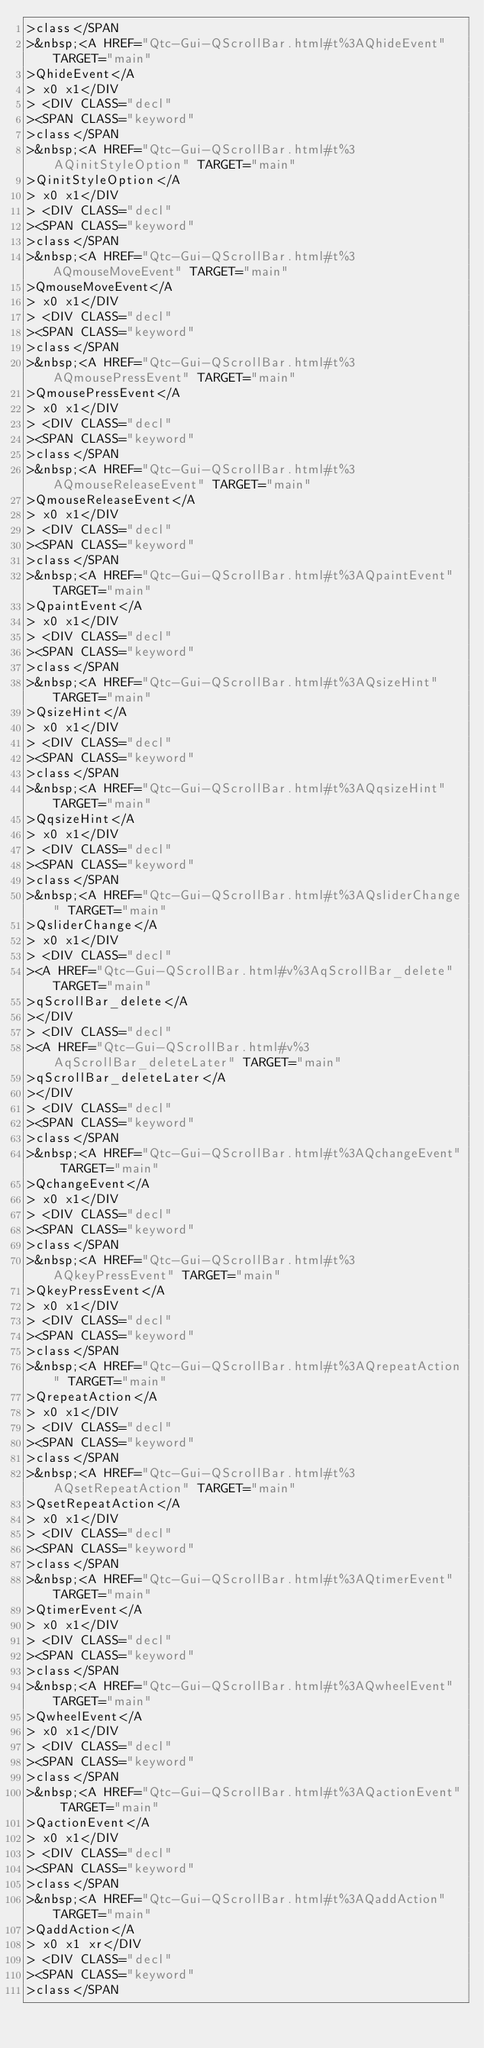Convert code to text. <code><loc_0><loc_0><loc_500><loc_500><_HTML_>>class</SPAN
>&nbsp;<A HREF="Qtc-Gui-QScrollBar.html#t%3AQhideEvent" TARGET="main"
>QhideEvent</A
> x0 x1</DIV
> <DIV CLASS="decl"
><SPAN CLASS="keyword"
>class</SPAN
>&nbsp;<A HREF="Qtc-Gui-QScrollBar.html#t%3AQinitStyleOption" TARGET="main"
>QinitStyleOption</A
> x0 x1</DIV
> <DIV CLASS="decl"
><SPAN CLASS="keyword"
>class</SPAN
>&nbsp;<A HREF="Qtc-Gui-QScrollBar.html#t%3AQmouseMoveEvent" TARGET="main"
>QmouseMoveEvent</A
> x0 x1</DIV
> <DIV CLASS="decl"
><SPAN CLASS="keyword"
>class</SPAN
>&nbsp;<A HREF="Qtc-Gui-QScrollBar.html#t%3AQmousePressEvent" TARGET="main"
>QmousePressEvent</A
> x0 x1</DIV
> <DIV CLASS="decl"
><SPAN CLASS="keyword"
>class</SPAN
>&nbsp;<A HREF="Qtc-Gui-QScrollBar.html#t%3AQmouseReleaseEvent" TARGET="main"
>QmouseReleaseEvent</A
> x0 x1</DIV
> <DIV CLASS="decl"
><SPAN CLASS="keyword"
>class</SPAN
>&nbsp;<A HREF="Qtc-Gui-QScrollBar.html#t%3AQpaintEvent" TARGET="main"
>QpaintEvent</A
> x0 x1</DIV
> <DIV CLASS="decl"
><SPAN CLASS="keyword"
>class</SPAN
>&nbsp;<A HREF="Qtc-Gui-QScrollBar.html#t%3AQsizeHint" TARGET="main"
>QsizeHint</A
> x0 x1</DIV
> <DIV CLASS="decl"
><SPAN CLASS="keyword"
>class</SPAN
>&nbsp;<A HREF="Qtc-Gui-QScrollBar.html#t%3AQqsizeHint" TARGET="main"
>QqsizeHint</A
> x0 x1</DIV
> <DIV CLASS="decl"
><SPAN CLASS="keyword"
>class</SPAN
>&nbsp;<A HREF="Qtc-Gui-QScrollBar.html#t%3AQsliderChange" TARGET="main"
>QsliderChange</A
> x0 x1</DIV
> <DIV CLASS="decl"
><A HREF="Qtc-Gui-QScrollBar.html#v%3AqScrollBar_delete" TARGET="main"
>qScrollBar_delete</A
></DIV
> <DIV CLASS="decl"
><A HREF="Qtc-Gui-QScrollBar.html#v%3AqScrollBar_deleteLater" TARGET="main"
>qScrollBar_deleteLater</A
></DIV
> <DIV CLASS="decl"
><SPAN CLASS="keyword"
>class</SPAN
>&nbsp;<A HREF="Qtc-Gui-QScrollBar.html#t%3AQchangeEvent" TARGET="main"
>QchangeEvent</A
> x0 x1</DIV
> <DIV CLASS="decl"
><SPAN CLASS="keyword"
>class</SPAN
>&nbsp;<A HREF="Qtc-Gui-QScrollBar.html#t%3AQkeyPressEvent" TARGET="main"
>QkeyPressEvent</A
> x0 x1</DIV
> <DIV CLASS="decl"
><SPAN CLASS="keyword"
>class</SPAN
>&nbsp;<A HREF="Qtc-Gui-QScrollBar.html#t%3AQrepeatAction" TARGET="main"
>QrepeatAction</A
> x0 x1</DIV
> <DIV CLASS="decl"
><SPAN CLASS="keyword"
>class</SPAN
>&nbsp;<A HREF="Qtc-Gui-QScrollBar.html#t%3AQsetRepeatAction" TARGET="main"
>QsetRepeatAction</A
> x0 x1</DIV
> <DIV CLASS="decl"
><SPAN CLASS="keyword"
>class</SPAN
>&nbsp;<A HREF="Qtc-Gui-QScrollBar.html#t%3AQtimerEvent" TARGET="main"
>QtimerEvent</A
> x0 x1</DIV
> <DIV CLASS="decl"
><SPAN CLASS="keyword"
>class</SPAN
>&nbsp;<A HREF="Qtc-Gui-QScrollBar.html#t%3AQwheelEvent" TARGET="main"
>QwheelEvent</A
> x0 x1</DIV
> <DIV CLASS="decl"
><SPAN CLASS="keyword"
>class</SPAN
>&nbsp;<A HREF="Qtc-Gui-QScrollBar.html#t%3AQactionEvent" TARGET="main"
>QactionEvent</A
> x0 x1</DIV
> <DIV CLASS="decl"
><SPAN CLASS="keyword"
>class</SPAN
>&nbsp;<A HREF="Qtc-Gui-QScrollBar.html#t%3AQaddAction" TARGET="main"
>QaddAction</A
> x0 x1 xr</DIV
> <DIV CLASS="decl"
><SPAN CLASS="keyword"
>class</SPAN</code> 